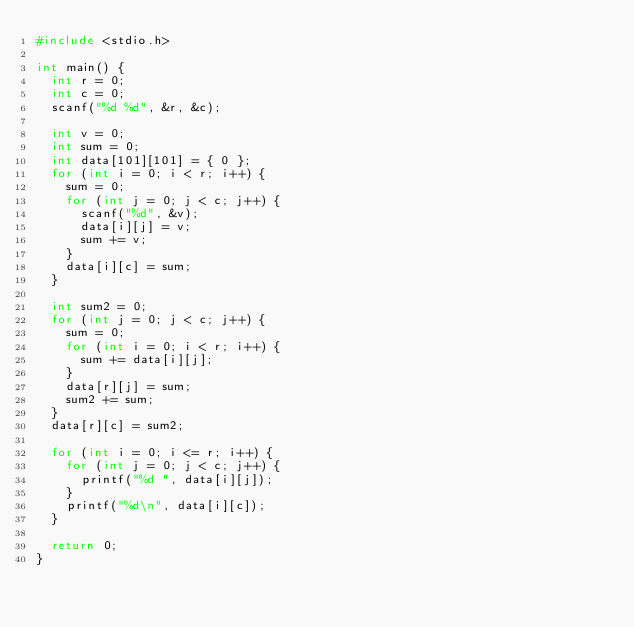<code> <loc_0><loc_0><loc_500><loc_500><_C_>#include <stdio.h>

int main() {
	int r = 0;
	int c = 0;
	scanf("%d %d", &r, &c);

	int v = 0;
	int sum = 0;
	int data[101][101] = { 0 };
	for (int i = 0; i < r; i++) {
		sum = 0;
		for (int j = 0; j < c; j++) {
			scanf("%d", &v);
			data[i][j] = v;
			sum += v;
		}
		data[i][c] = sum;
	}

	int sum2 = 0;
	for (int j = 0; j < c; j++) {
		sum = 0;
		for (int i = 0; i < r; i++) {
			sum += data[i][j];
		}
		data[r][j] = sum;
		sum2 += sum;
	}
	data[r][c] = sum2;

	for (int i = 0; i <= r; i++) {
		for (int j = 0; j < c; j++) {
			printf("%d ", data[i][j]);
		}
		printf("%d\n", data[i][c]);
	}

	return 0;
}</code> 